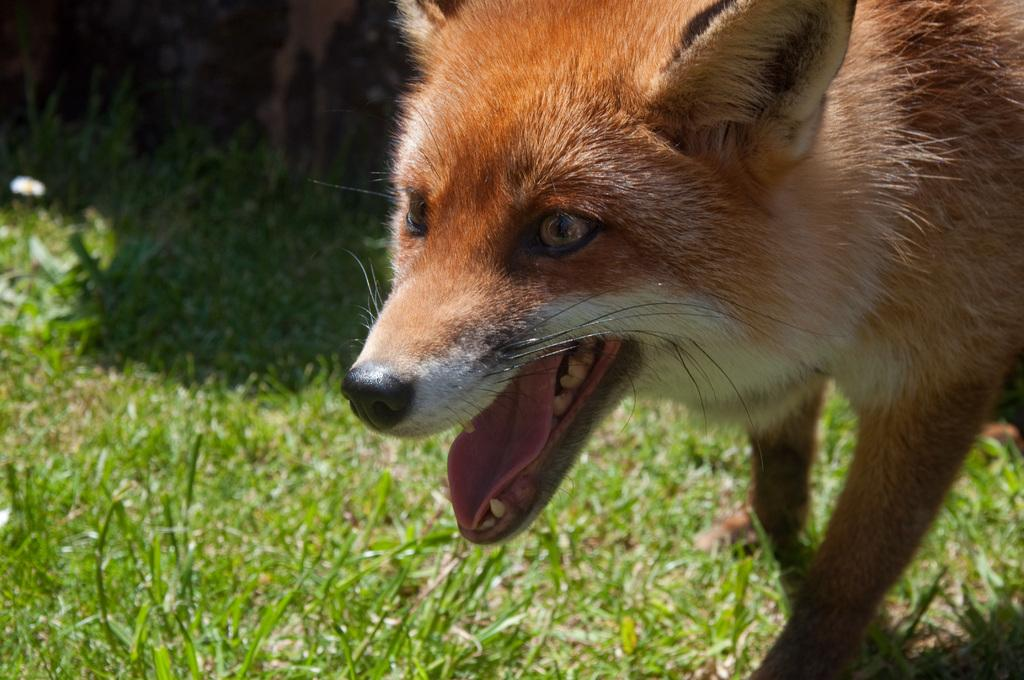What type of animal is present in the image? There is an animal in the image, but the specific type cannot be determined from the provided facts. What can be seen in the background of the image? There is grass in the image. Where is the throne located in the image? There is no throne present in the image. What decision is the animal making in the image? There is no indication of a decision being made by the animal in the image. 